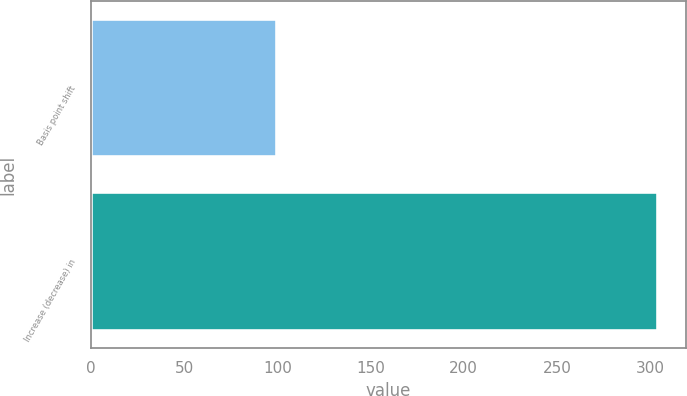Convert chart. <chart><loc_0><loc_0><loc_500><loc_500><bar_chart><fcel>Basis point shift<fcel>Increase (decrease) in<nl><fcel>100<fcel>304<nl></chart> 